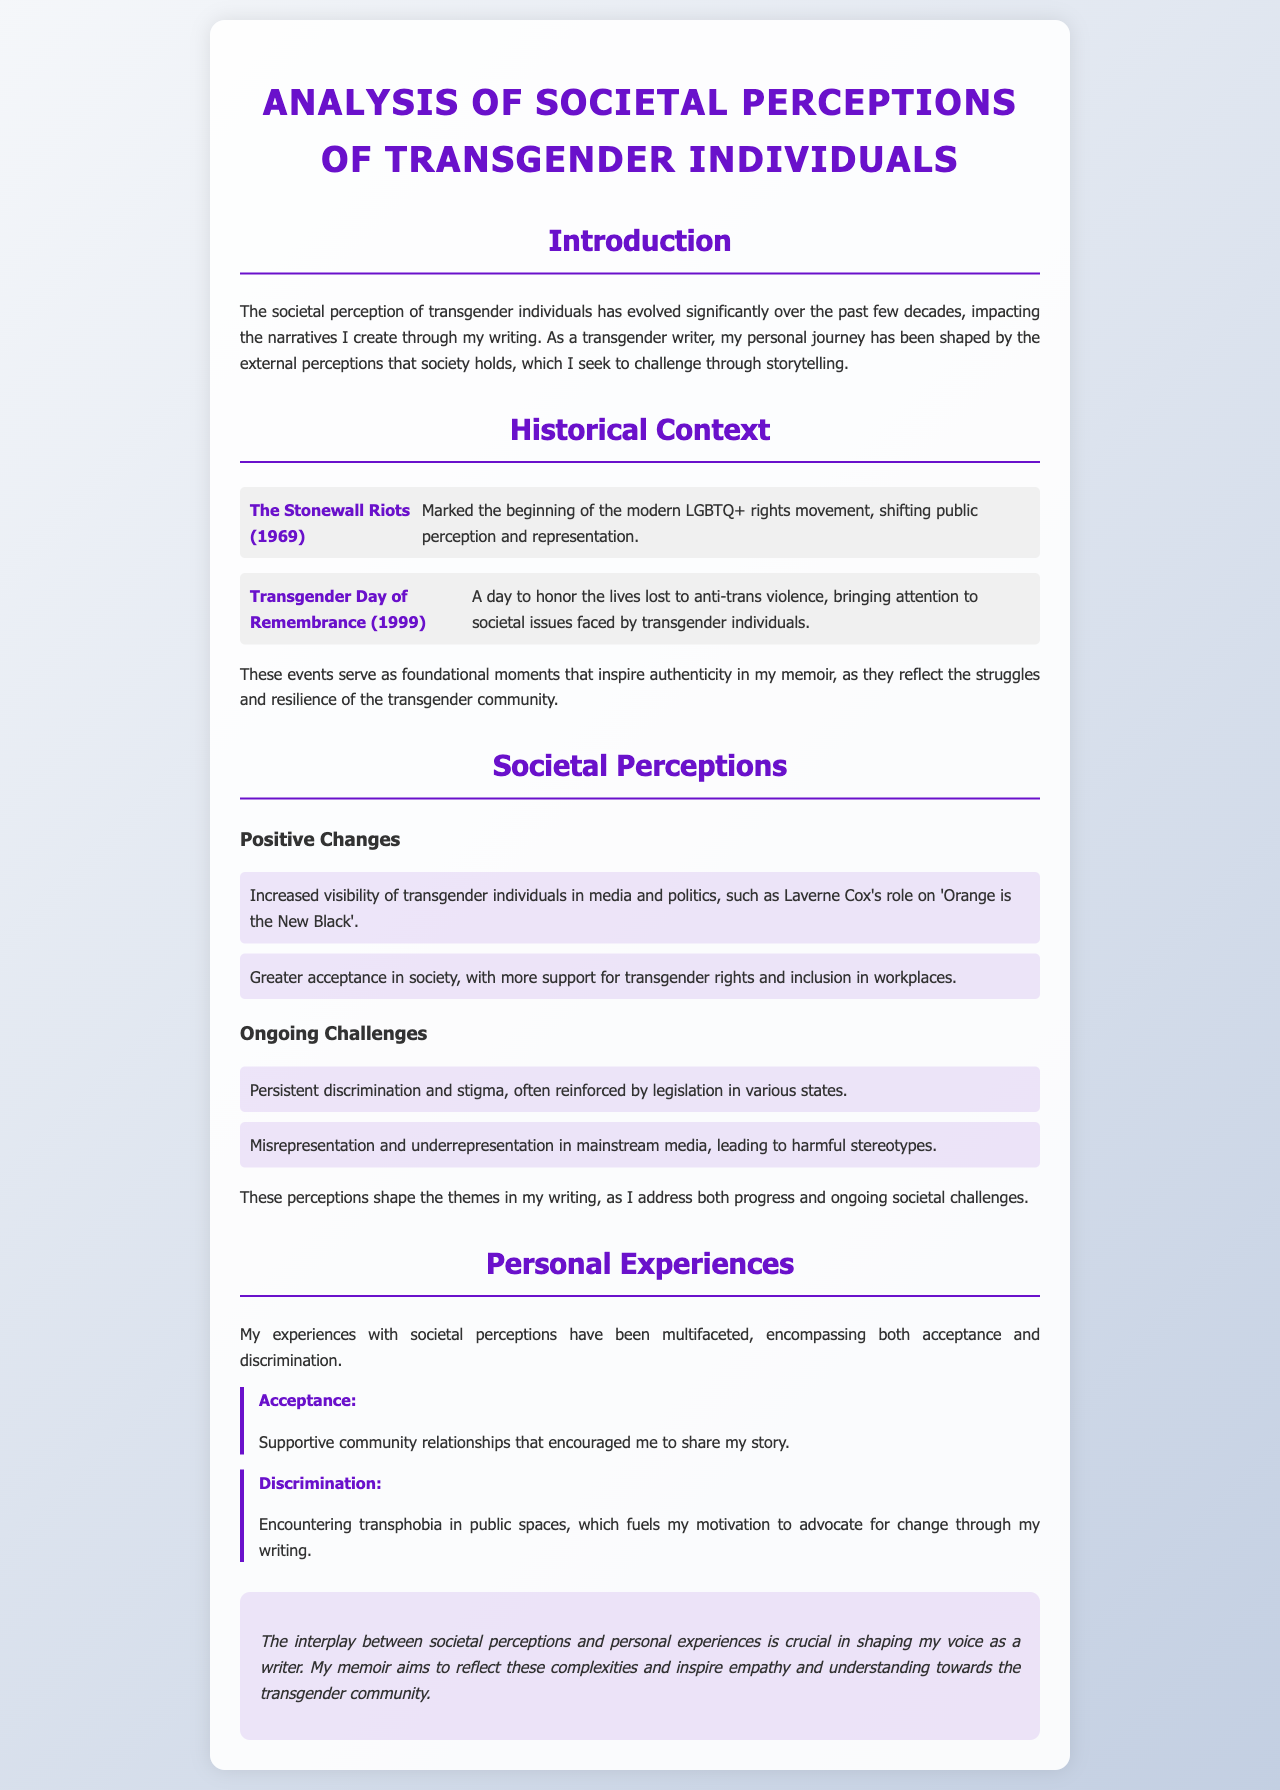What marked the beginning of the modern LGBTQ+ rights movement? The document mentions the Stonewall Riots as the significant event that initiated the modern LGBTQ+ rights movement.
Answer: The Stonewall Riots When was the Transgender Day of Remembrance first observed? The document states that the Transgender Day of Remembrance was established in 1999.
Answer: 1999 What is one positive change in societal perceptions of transgender individuals mentioned? The document lists increased visibility of transgender individuals in media and politics as a positive change.
Answer: Increased visibility What motivates the author's writing in response to discrimination? The author states that encountering transphobia in public spaces fuels their motivation to advocate for change through writing.
Answer: Advocacy for change What do the events mentioned in the historical context inspire in the author's memoir? The author reflects that these foundational moments inspire authenticity in their memoir.
Answer: Authenticity What is one ongoing challenge faced by transgender individuals according to the document? The document notes persistent discrimination and stigma as a challenge that continues to affect transgender individuals.
Answer: Discrimination How does the author describe the importance of personal experiences in their writing? The author emphasizes the interplay between societal perceptions and personal experiences as crucial in shaping their voice as a writer.
Answer: Crucial interplay What tone does the conclusion of the document adopt? The conclusion of the document is stated to be italicized, suggesting a reflective tone.
Answer: Reflective tone What color is used for headings in the document? The document specifies that the headings are in a shade of purple represented by the color code #6a11cb.
Answer: Purple 